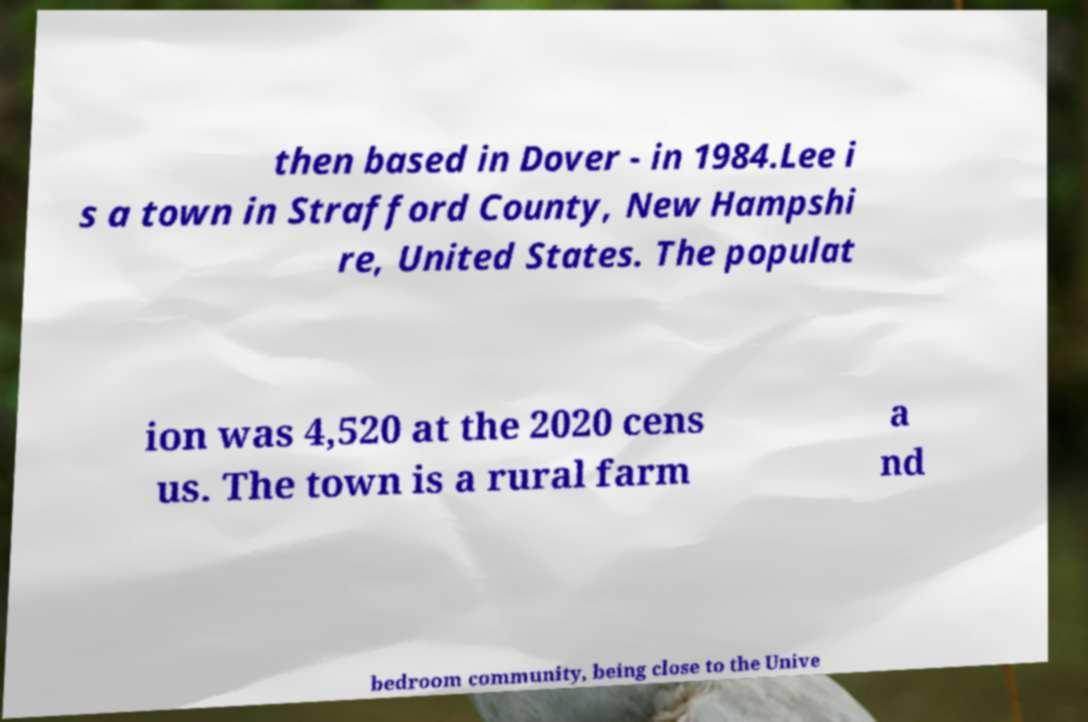What messages or text are displayed in this image? I need them in a readable, typed format. then based in Dover - in 1984.Lee i s a town in Strafford County, New Hampshi re, United States. The populat ion was 4,520 at the 2020 cens us. The town is a rural farm a nd bedroom community, being close to the Unive 